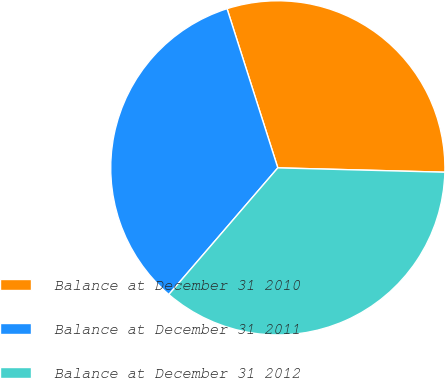Convert chart. <chart><loc_0><loc_0><loc_500><loc_500><pie_chart><fcel>Balance at December 31 2010<fcel>Balance at December 31 2011<fcel>Balance at December 31 2012<nl><fcel>30.33%<fcel>33.78%<fcel>35.89%<nl></chart> 